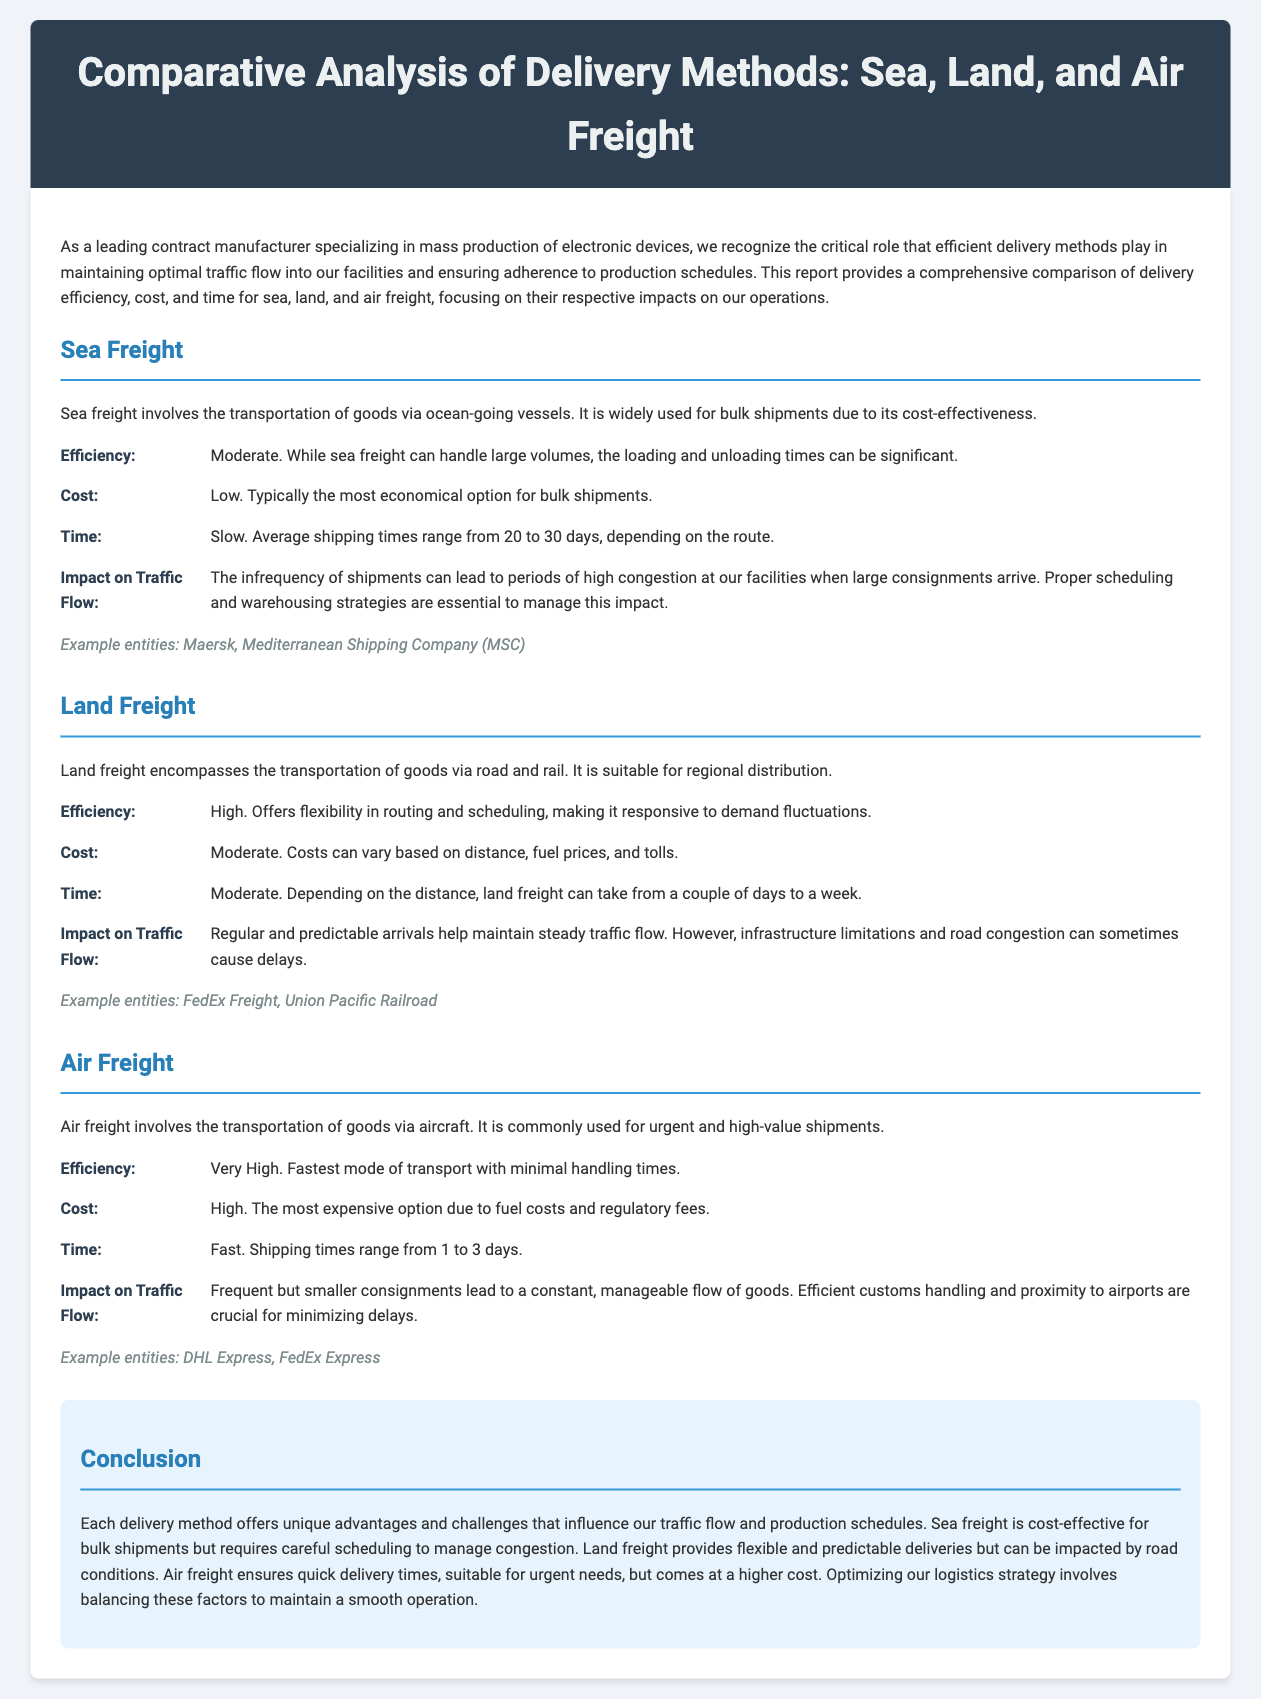What are the three delivery methods compared in the report? The report compares sea, land, and air freight as delivery methods.
Answer: Sea, Land, Air What is the time range for sea freight shipments? The report states that average shipping times for sea freight range from 20 to 30 days.
Answer: 20 to 30 days What is the cost classification of air freight? The report mentions that air freight is classified as the most expensive option due to various costs.
Answer: High How does land freight impact traffic flow? The document notes that regular and predictable arrivals help maintain steady traffic flow.
Answer: Steady traffic flow What type of shipments is air freight commonly used for? According to the report, air freight is commonly used for urgent and high-value shipments.
Answer: Urgent and high-value shipments What is the efficiency level of sea freight? The report identifies the efficiency of sea freight as moderate.
Answer: Moderate How long does land freight typically take for deliveries? The document states that land freight can take a couple of days to a week depending on the distance.
Answer: A couple of days to a week Which delivery method has the fastest shipping times? The report indicates that air freight has the fastest shipping times among the three methods.
Answer: Air freight What is the impact of sea freight on traffic flow? The report indicates that infrequent shipments can lead to periods of high congestion at facilities.
Answer: High congestion 